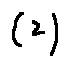<formula> <loc_0><loc_0><loc_500><loc_500>( 2 )</formula> 